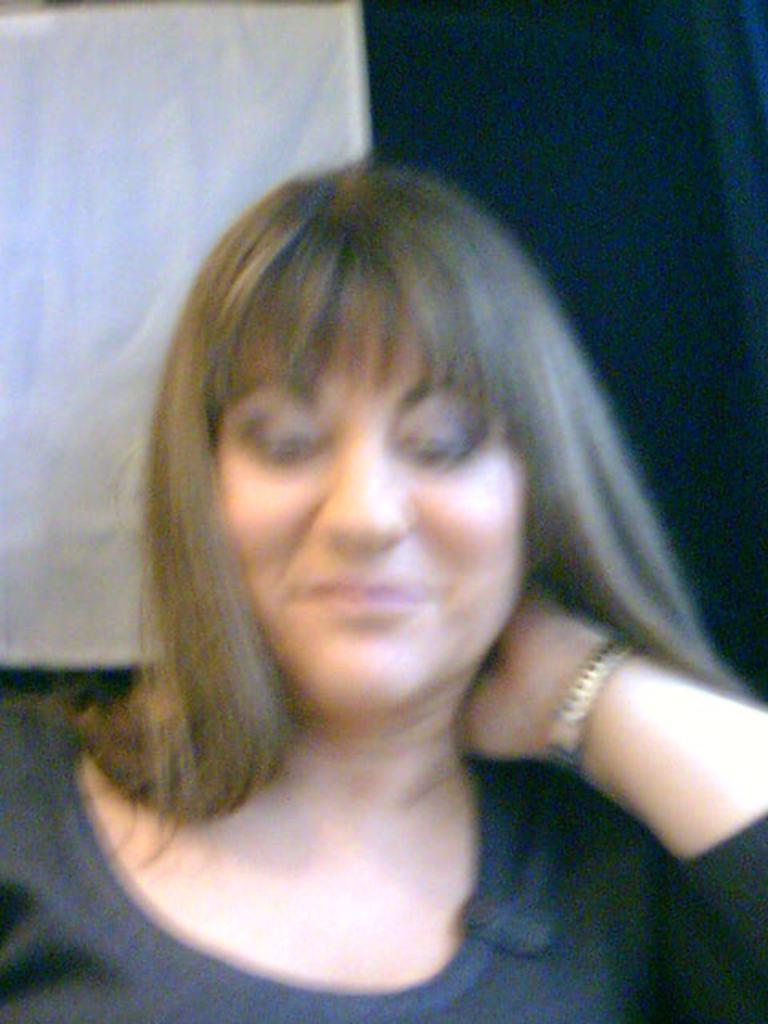What is the overall quality of the image? The image is blurred. Can you identify any people in the image? Yes, there is a woman in the image. What can be seen in the background of the image? There is a curtain in the background of the image. What type of scent can be detected in the image? There is no information about scent in the image, as it is a visual medium. 